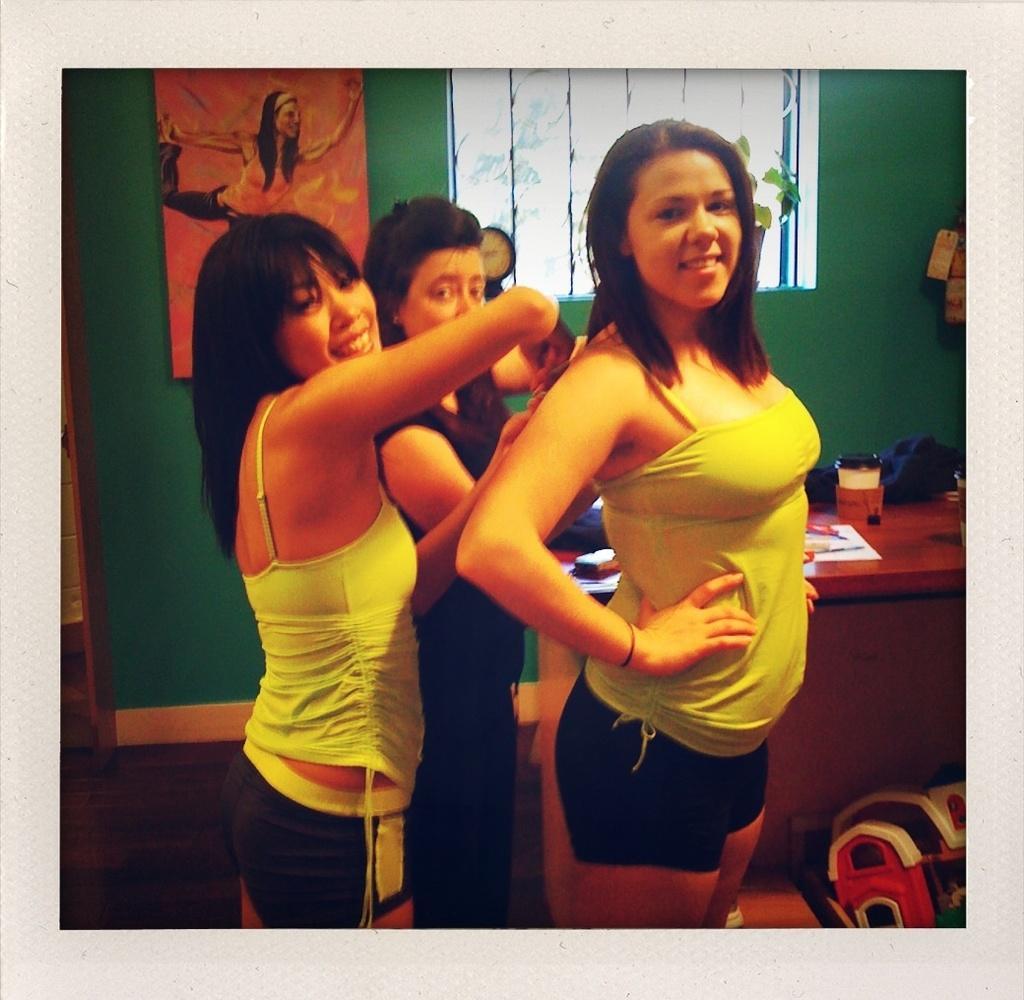In one or two sentences, can you explain what this image depicts? There is a woman in a light green color jacket, smiling, standing and holding dress of the other woman who is standing and smiling. In the background, there is another person, a photo frame on the green wall which is having a window and there are some objects on the table. 